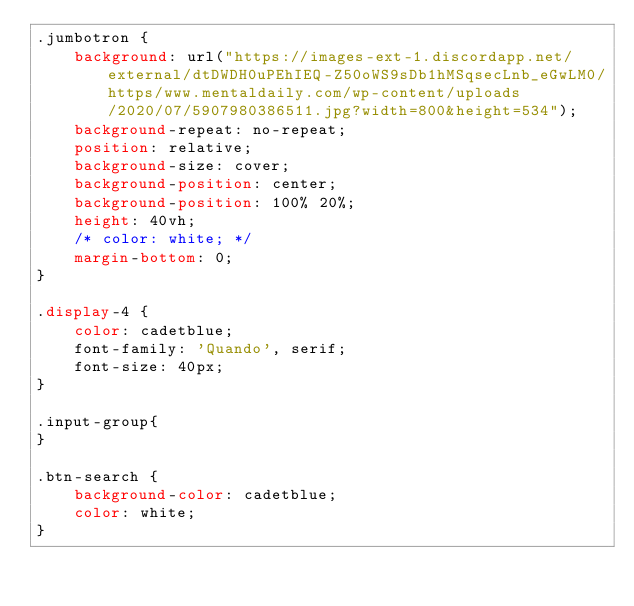Convert code to text. <code><loc_0><loc_0><loc_500><loc_500><_CSS_>.jumbotron {
    background: url("https://images-ext-1.discordapp.net/external/dtDWDH0uPEhIEQ-Z50oWS9sDb1hMSqsecLnb_eGwLM0/https/www.mentaldaily.com/wp-content/uploads/2020/07/5907980386511.jpg?width=800&height=534");
    background-repeat: no-repeat;
    position: relative;
    background-size: cover;
    background-position: center;
    background-position: 100% 20%;
    height: 40vh;
    /* color: white; */
    margin-bottom: 0;
}

.display-4 {
    color: cadetblue;
    font-family: 'Quando', serif;
    font-size: 40px;
}

.input-group{
}

.btn-search {
    background-color: cadetblue;
    color: white;
}
</code> 